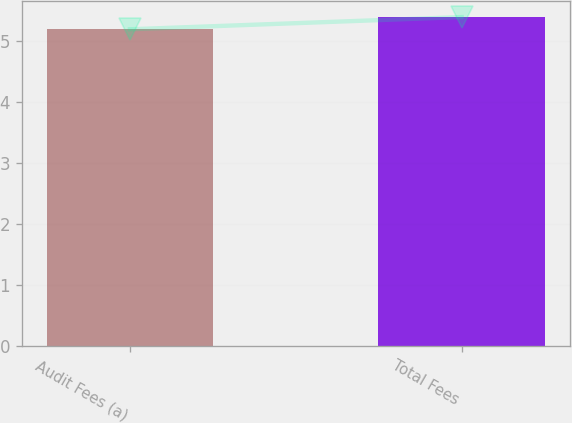Convert chart to OTSL. <chart><loc_0><loc_0><loc_500><loc_500><bar_chart><fcel>Audit Fees (a)<fcel>Total Fees<nl><fcel>5.2<fcel>5.4<nl></chart> 